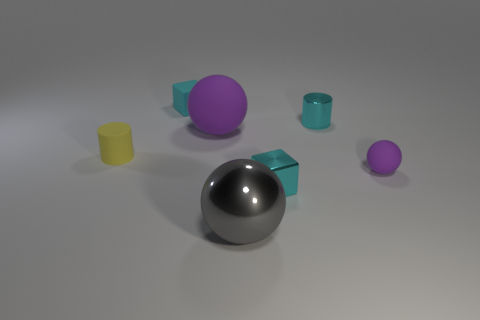What is the color of the sphere that is the same size as the gray thing?
Provide a short and direct response. Purple. Is there another gray metallic object that has the same shape as the big shiny object?
Provide a succinct answer. No. What is the shape of the small object that is the same color as the large matte object?
Provide a succinct answer. Sphere. Are there any tiny purple things to the left of the cyan object that is in front of the tiny cyan metal object behind the large purple sphere?
Your answer should be very brief. No. There is a yellow rubber object that is the same size as the cyan rubber cube; what is its shape?
Give a very brief answer. Cylinder. What is the color of the large metallic thing that is the same shape as the large purple matte object?
Your answer should be compact. Gray. What number of things are either large cyan shiny spheres or gray balls?
Offer a terse response. 1. There is a small metal object that is in front of the tiny shiny cylinder; is it the same shape as the rubber object that is to the right of the gray thing?
Give a very brief answer. No. There is a tiny rubber thing that is right of the tiny metal block; what is its shape?
Ensure brevity in your answer.  Sphere. Are there an equal number of small objects behind the tiny purple rubber thing and purple matte objects behind the cyan metallic cylinder?
Keep it short and to the point. No. 